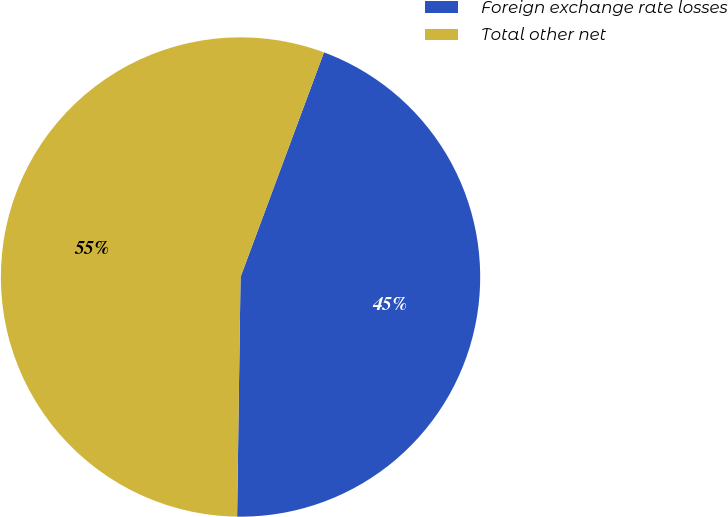Convert chart. <chart><loc_0><loc_0><loc_500><loc_500><pie_chart><fcel>Foreign exchange rate losses<fcel>Total other net<nl><fcel>44.57%<fcel>55.43%<nl></chart> 